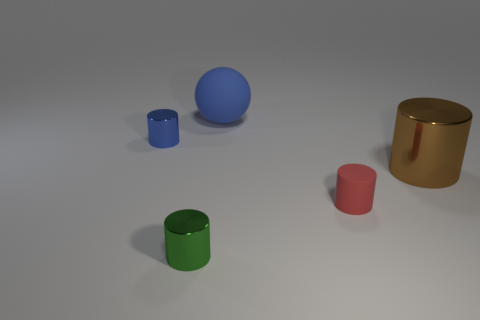Are there any small cylinders that have the same material as the big cylinder?
Offer a very short reply. Yes. What number of other big blue matte things are the same shape as the large matte thing?
Offer a terse response. 0. There is a blue object that is behind the shiny thing behind the big thing that is on the right side of the red rubber object; what shape is it?
Offer a very short reply. Sphere. The thing that is both to the left of the red matte cylinder and on the right side of the tiny green cylinder is made of what material?
Your response must be concise. Rubber. There is a metallic cylinder that is to the right of the red matte object; does it have the same size as the blue metallic thing?
Offer a very short reply. No. Are there any other things that have the same size as the blue metal cylinder?
Offer a very short reply. Yes. Is the number of big brown shiny cylinders in front of the tiny red object greater than the number of large objects behind the brown cylinder?
Offer a very short reply. No. What is the color of the rubber object that is behind the shiny object behind the big object that is in front of the blue cylinder?
Offer a very short reply. Blue. Do the tiny metal thing that is right of the small blue cylinder and the matte ball have the same color?
Give a very brief answer. No. What number of other things are the same color as the rubber ball?
Make the answer very short. 1. 